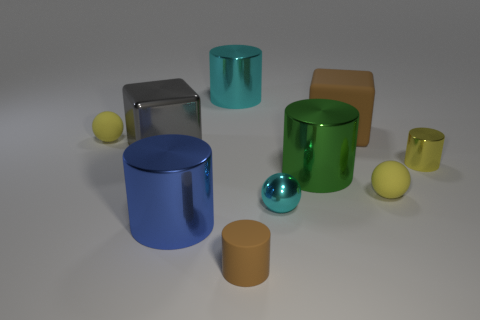What shape is the matte object that is on the left side of the green thing and behind the small shiny sphere?
Your response must be concise. Sphere. There is a small matte sphere that is left of the big gray cube; is it the same color as the matte sphere right of the matte cylinder?
Ensure brevity in your answer.  Yes. There is a thing that is the same color as the small metallic ball; what size is it?
Give a very brief answer. Large. Are there any gray blocks made of the same material as the big cyan cylinder?
Provide a short and direct response. Yes. Are there an equal number of tiny cyan balls that are to the left of the blue shiny cylinder and big gray cubes that are in front of the yellow cylinder?
Your answer should be compact. Yes. What is the size of the cyan object behind the big brown matte block?
Provide a succinct answer. Large. The gray block that is to the left of the brown thing behind the yellow metal thing is made of what material?
Your answer should be very brief. Metal. What number of small cyan metal balls are behind the big cube behind the yellow rubber thing on the left side of the large brown matte thing?
Make the answer very short. 0. Is the material of the small sphere that is to the left of the gray cube the same as the tiny yellow sphere on the right side of the gray object?
Offer a very short reply. Yes. What material is the tiny thing that is the same color as the large rubber block?
Offer a terse response. Rubber. 